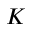Convert formula to latex. <formula><loc_0><loc_0><loc_500><loc_500>K</formula> 